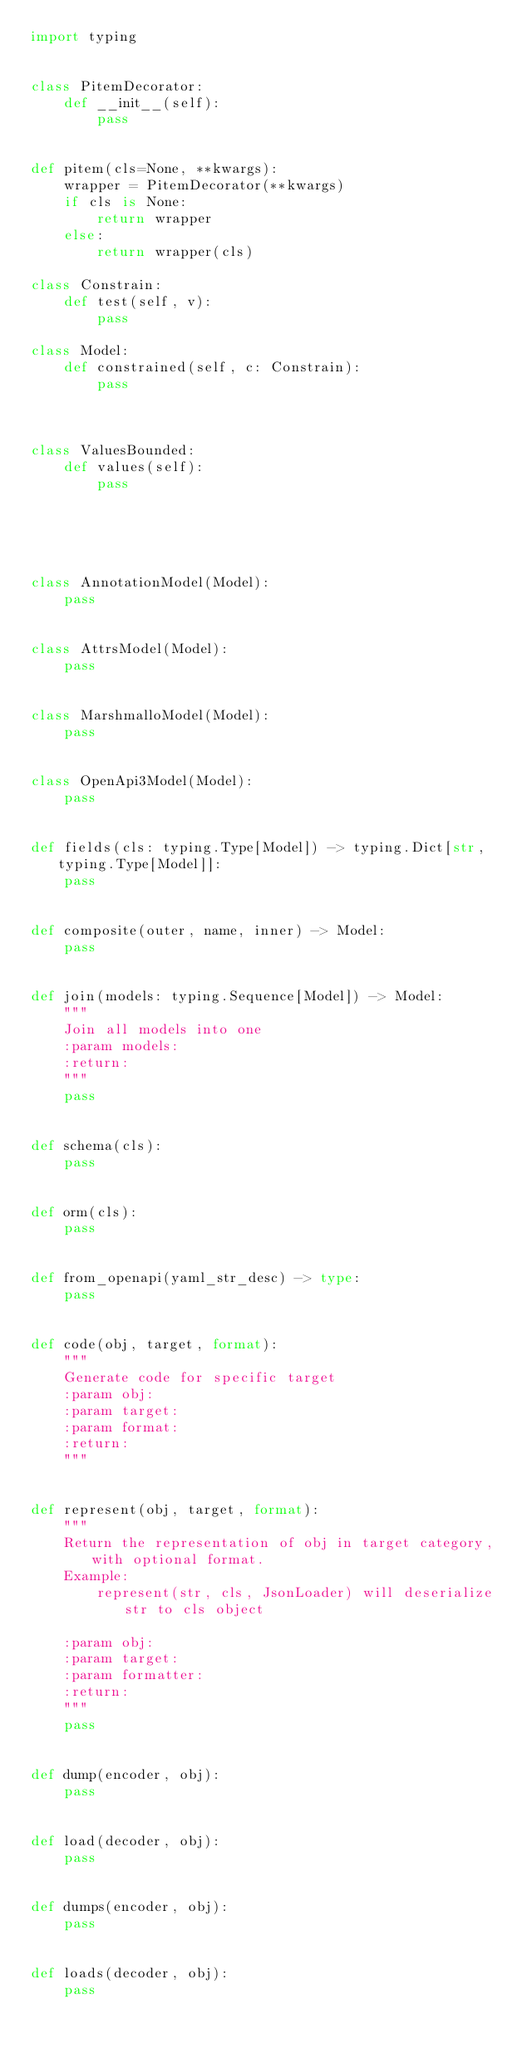Convert code to text. <code><loc_0><loc_0><loc_500><loc_500><_Python_>import typing


class PitemDecorator:
    def __init__(self):
        pass


def pitem(cls=None, **kwargs):
    wrapper = PitemDecorator(**kwargs)
    if cls is None:
        return wrapper
    else:
        return wrapper(cls)

class Constrain:
    def test(self, v):
        pass

class Model:
    def constrained(self, c: Constrain):
        pass



class ValuesBounded:
    def values(self):
        pass





class AnnotationModel(Model):
    pass


class AttrsModel(Model):
    pass


class MarshmalloModel(Model):
    pass


class OpenApi3Model(Model):
    pass


def fields(cls: typing.Type[Model]) -> typing.Dict[str, typing.Type[Model]]:
    pass


def composite(outer, name, inner) -> Model:
    pass


def join(models: typing.Sequence[Model]) -> Model:
    """
    Join all models into one
    :param models:
    :return:
    """
    pass


def schema(cls):
    pass


def orm(cls):
    pass


def from_openapi(yaml_str_desc) -> type:
    pass


def code(obj, target, format):
    """
    Generate code for specific target
    :param obj:
    :param target:
    :param format:
    :return:
    """


def represent(obj, target, format):
    """
    Return the representation of obj in target category, with optional format.
    Example:
        represent(str, cls, JsonLoader) will deserialize str to cls object

    :param obj:
    :param target:
    :param formatter:
    :return:
    """
    pass


def dump(encoder, obj):
    pass


def load(decoder, obj):
    pass


def dumps(encoder, obj):
    pass


def loads(decoder, obj):
    pass
</code> 